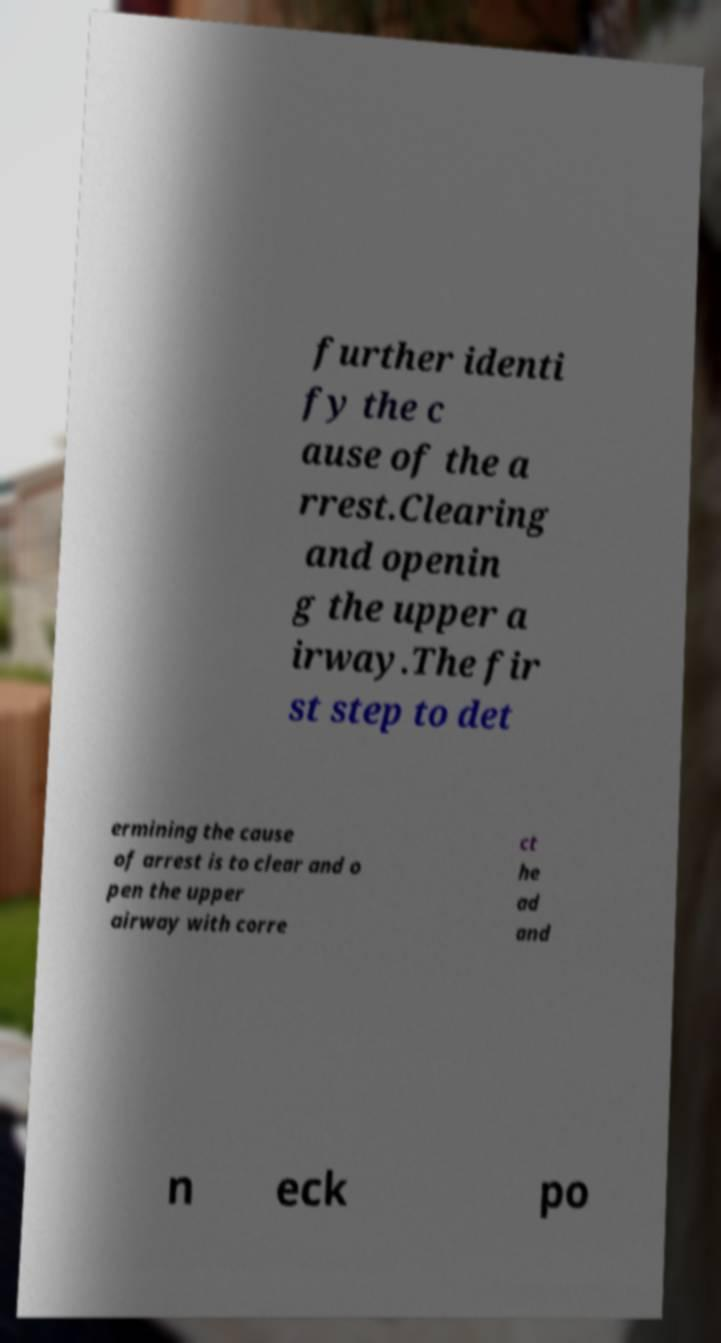Can you accurately transcribe the text from the provided image for me? further identi fy the c ause of the a rrest.Clearing and openin g the upper a irway.The fir st step to det ermining the cause of arrest is to clear and o pen the upper airway with corre ct he ad and n eck po 